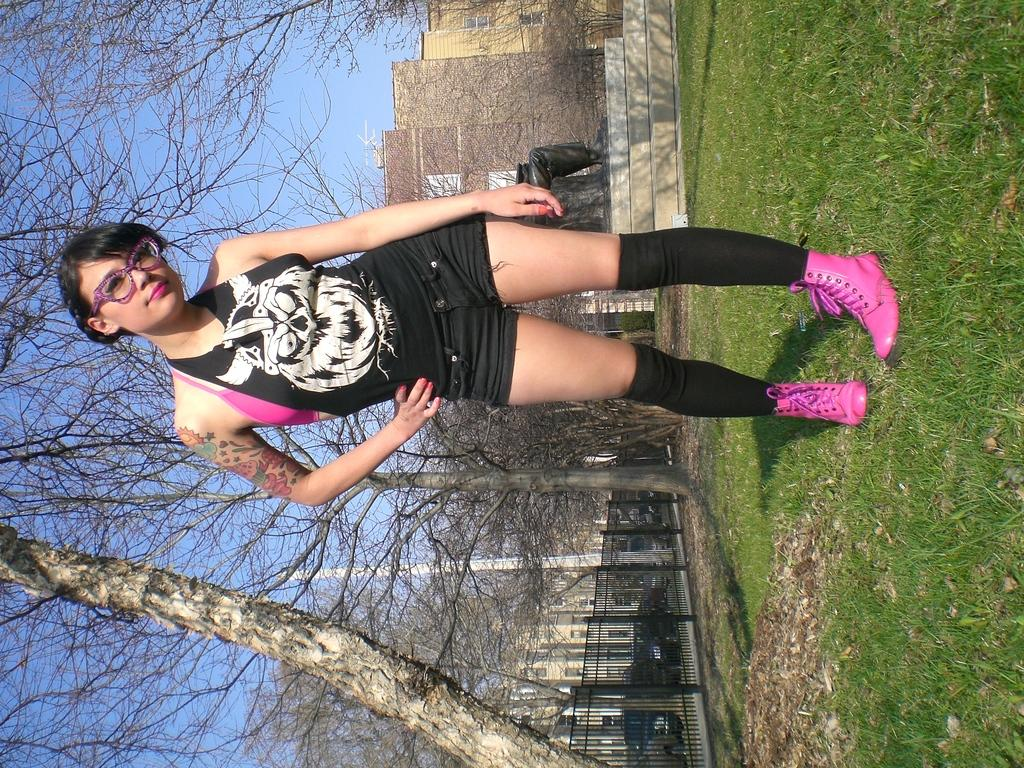Who is the main subject in the image? There is a woman in the front of the image. What is the landscape like in the image? The land is covered with grass. What can be seen in the background of the image? There are trees, buildings, railings, vehicles, a pole, a statue, and the sky visible in the background. What type of table is being used as a design element in the image? There is no table present in the image. What kind of arch can be seen in the background of the image? There is no arch visible in the image. 